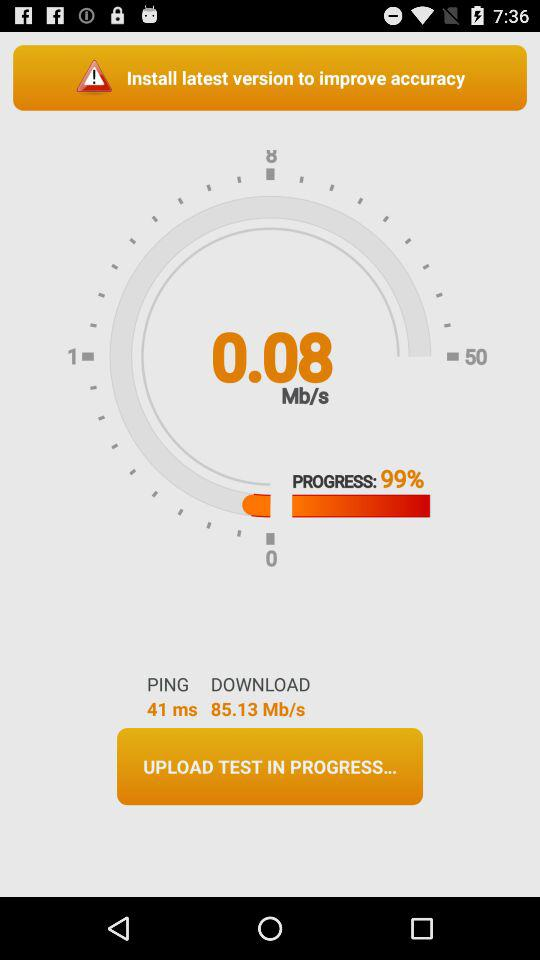What is the percentage of completion of the speed test?
Answer the question using a single word or phrase. 99% 